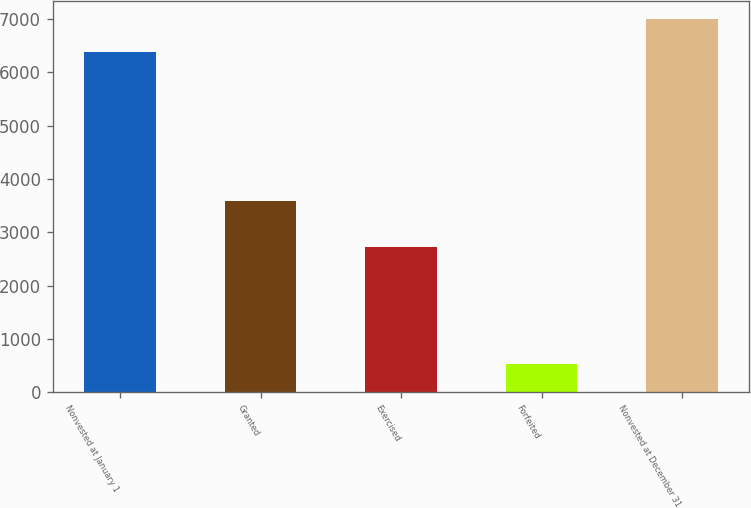Convert chart to OTSL. <chart><loc_0><loc_0><loc_500><loc_500><bar_chart><fcel>Nonvested at January 1<fcel>Granted<fcel>Exercised<fcel>Forfeited<fcel>Nonvested at December 31<nl><fcel>6379<fcel>3583<fcel>2720<fcel>532<fcel>6996.8<nl></chart> 